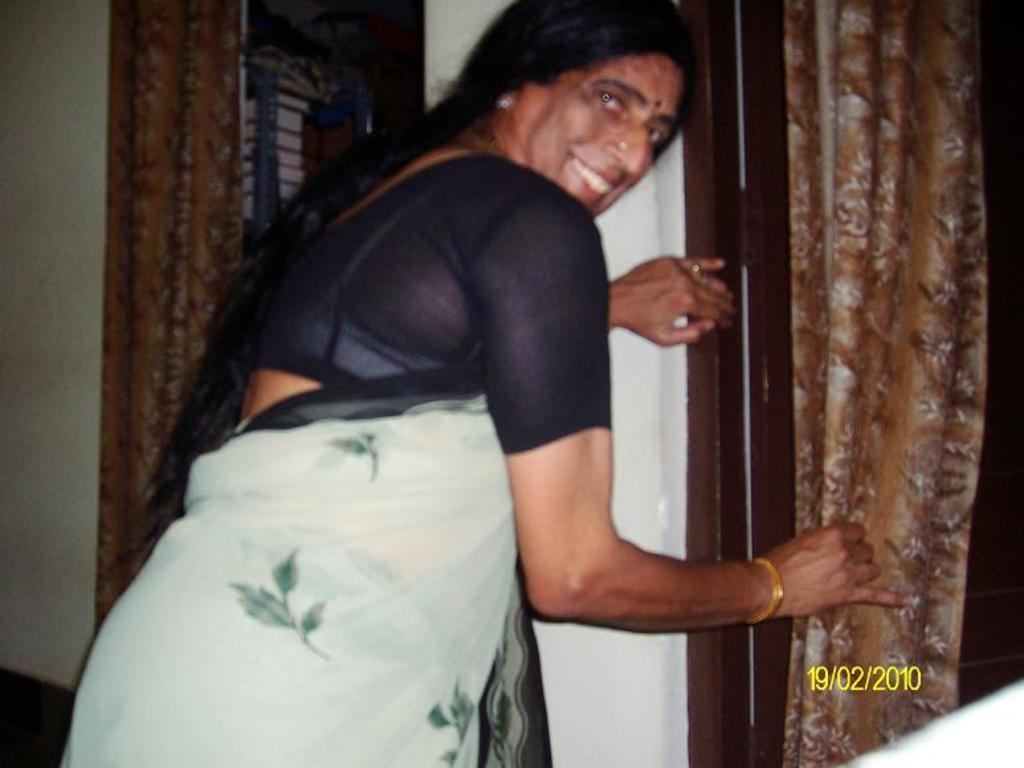What is the primary subject in the image? There is a woman standing in the image. What can be seen in the background of the image? There is a wall, curtains, a door, and other objects in the background of the image. Can you describe the date in the bottom right corner of the image? Yes, there is a date in the bottom right corner of the image. What type of marble is the woman holding in the image? There is no marble present in the image; the woman is not holding anything. How many grapes can be seen on the woman's head in the image? There are no grapes present in the image; the woman's head is not adorned with any grapes. 